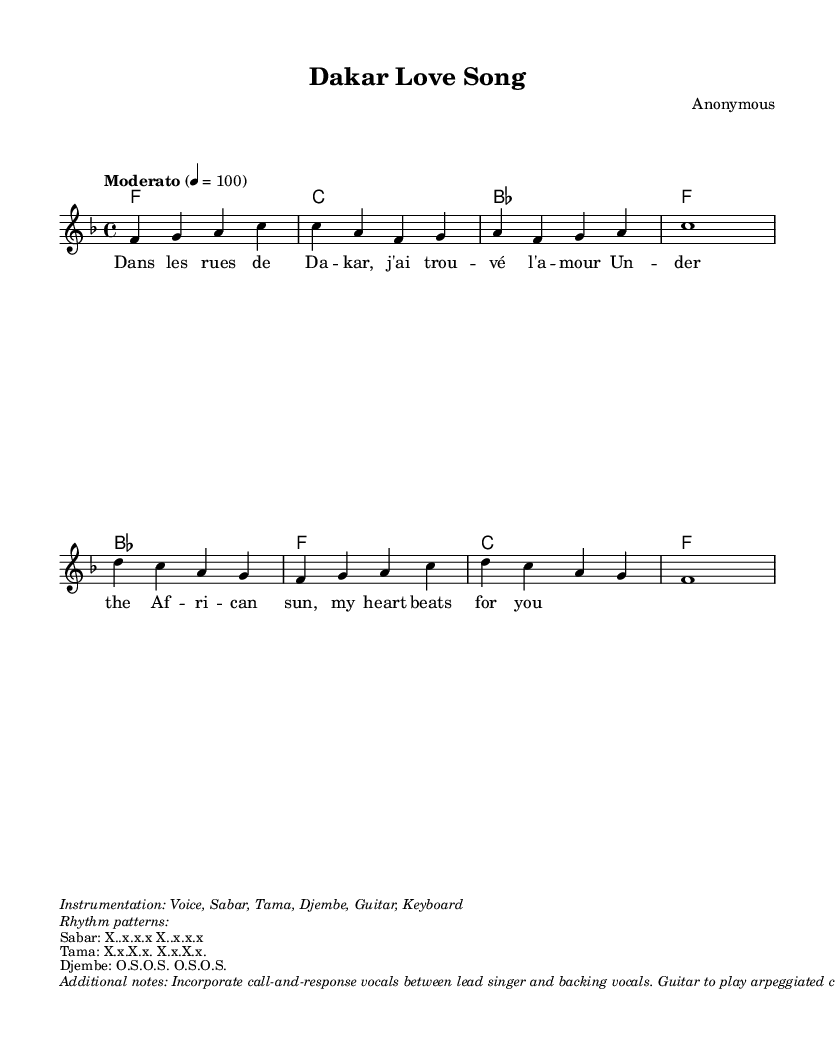What is the key signature of this music? The key signature for this piece is F major, which has one flat (B flat). It's indicated at the beginning of the staff.
Answer: F major What is the time signature of this music? The time signature is 4/4, as indicated at the beginning of the score, which means there are four beats in each measure.
Answer: 4/4 What is the tempo marking provided in the sheet music? The tempo marking is "Moderato," which suggests a moderate pace, specifically at a metronome marking of 100 beats per minute.
Answer: Moderato How many measures are there in the melody section? By counting the measures in the melody part, there are a total of 8 measures. This helps in understanding the structure of the melody.
Answer: 8 measures What type of instruments are indicated in the instrumentation? The sheet music specifies the instruments as Voice, Sabar, Tama, Djembe, Guitar, and Keyboard. These instruments are characteristic of Senegalese music styles.
Answer: Voice, Sabar, Tama, Djembe, Guitar, Keyboard What lyric theme is presented in the song? The theme revolves around finding love in the vibrant streets of Dakar, highlighted by phrases like "dans les rues de Dakar, j'ai trouvé l'amour." This conveys the Romantic aspect of the music.
Answer: Finding love in Dakar What rhythmic pattern is used in the Sabar? The rhythmic pattern for the Sabar is "X..x.x.x," which represents a specific beat structure often found in Mbalax music, emphasizing the danceable nature of the genre.
Answer: X..x.x.x 